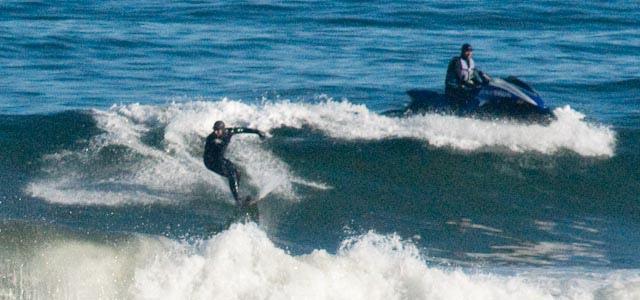How many airplane wheels are to be seen?
Give a very brief answer. 0. 